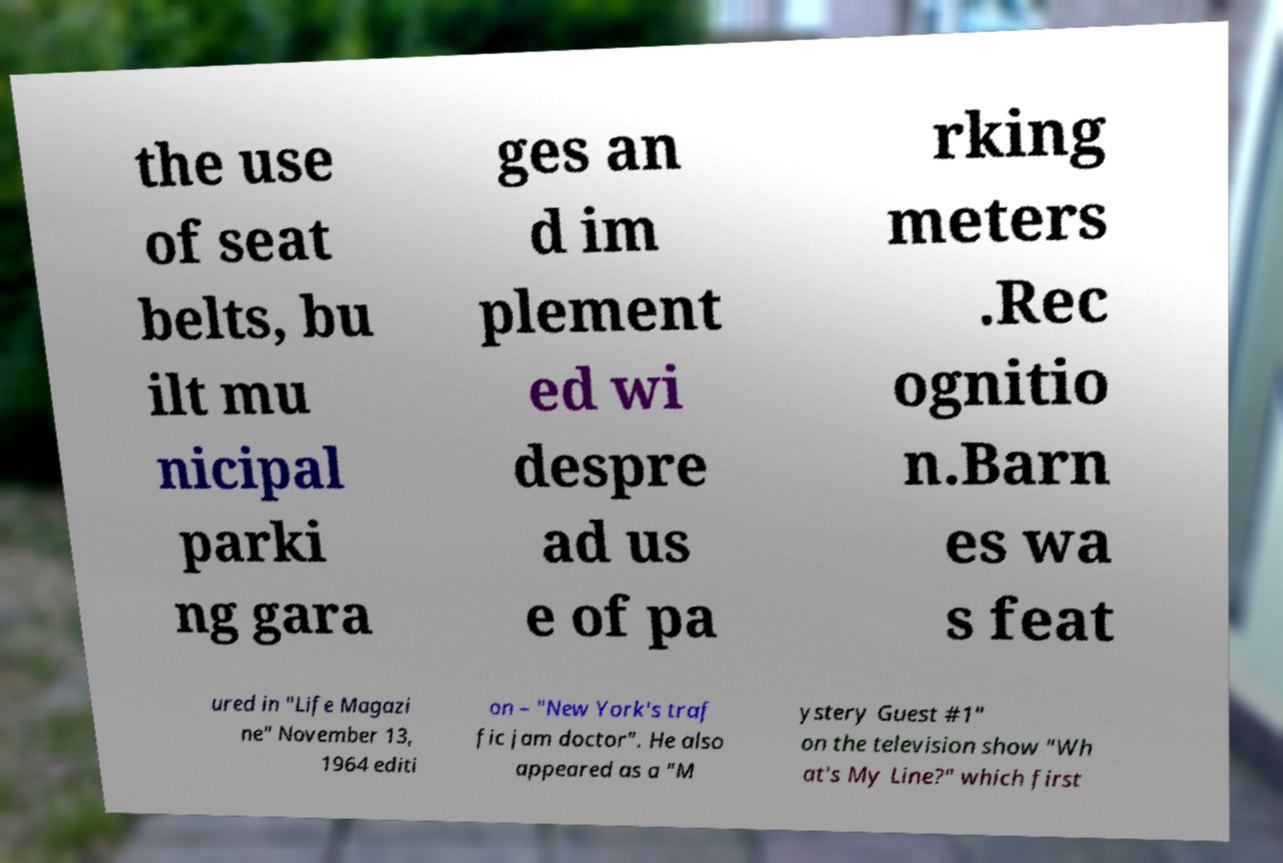Please read and relay the text visible in this image. What does it say? the use of seat belts, bu ilt mu nicipal parki ng gara ges an d im plement ed wi despre ad us e of pa rking meters .Rec ognitio n.Barn es wa s feat ured in "Life Magazi ne" November 13, 1964 editi on – "New York's traf fic jam doctor". He also appeared as a "M ystery Guest #1" on the television show "Wh at's My Line?" which first 